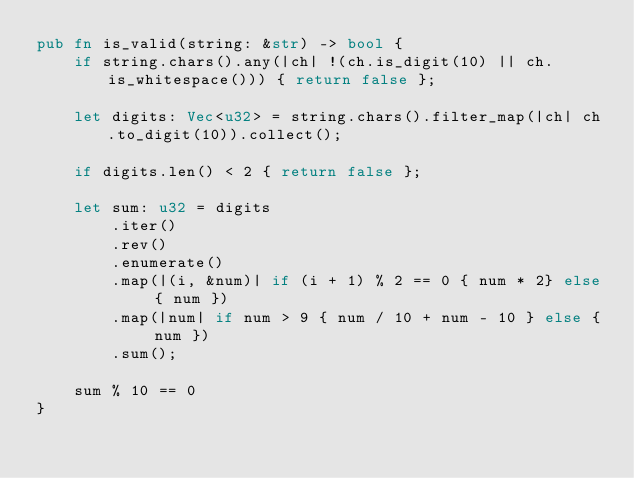Convert code to text. <code><loc_0><loc_0><loc_500><loc_500><_Rust_>pub fn is_valid(string: &str) -> bool {
    if string.chars().any(|ch| !(ch.is_digit(10) || ch.is_whitespace())) { return false };

    let digits: Vec<u32> = string.chars().filter_map(|ch| ch.to_digit(10)).collect();

    if digits.len() < 2 { return false };

    let sum: u32 = digits
        .iter()
        .rev()
        .enumerate()
        .map(|(i, &num)| if (i + 1) % 2 == 0 { num * 2} else { num })
        .map(|num| if num > 9 { num / 10 + num - 10 } else { num })
        .sum();

    sum % 10 == 0
}
</code> 